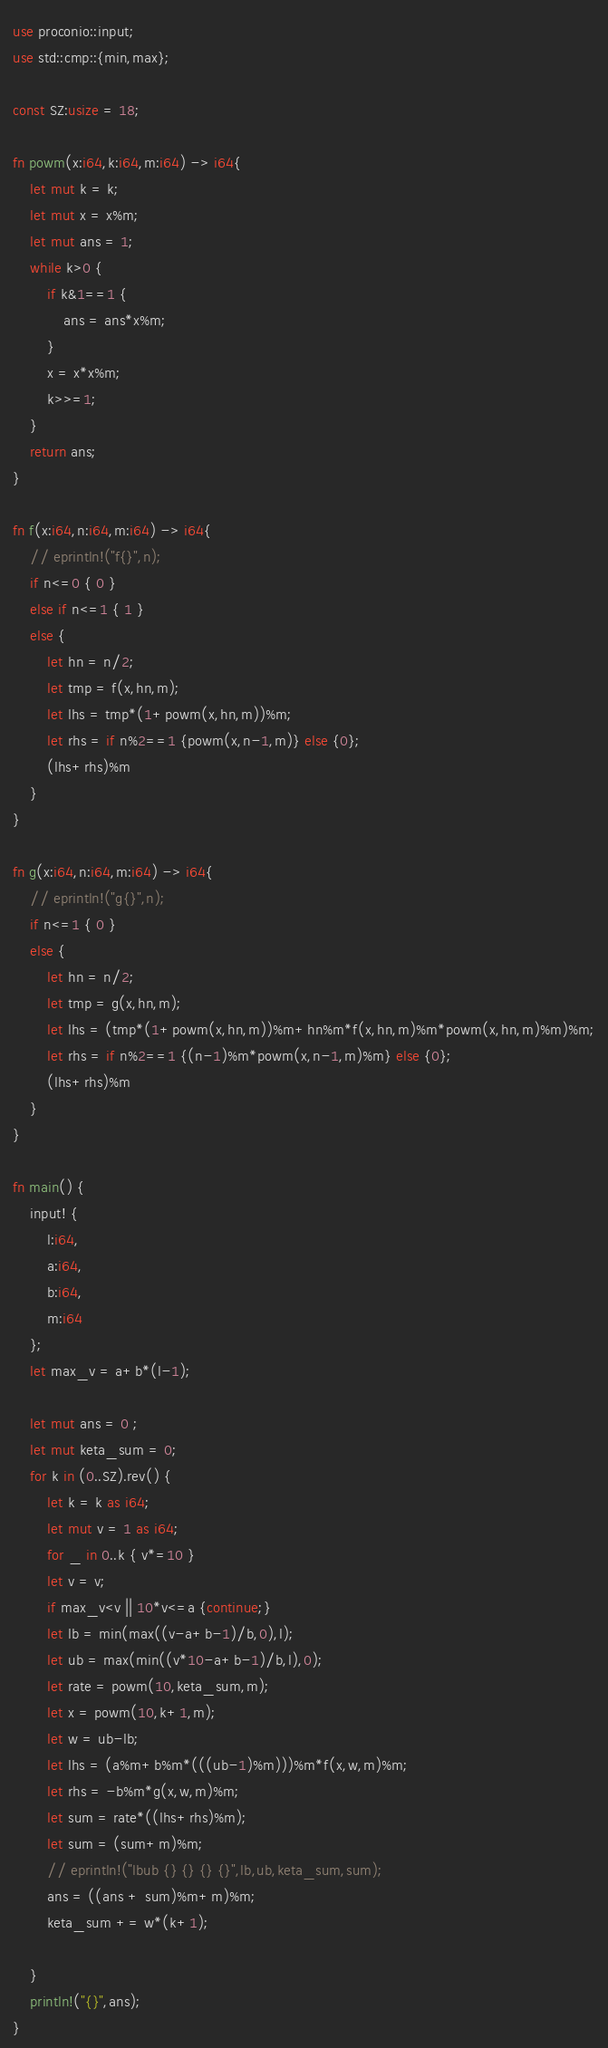Convert code to text. <code><loc_0><loc_0><loc_500><loc_500><_Rust_>use proconio::input;
use std::cmp::{min,max};

const SZ:usize = 18;

fn powm(x:i64,k:i64,m:i64) -> i64{
    let mut k = k;
    let mut x = x%m;
    let mut ans = 1;
    while k>0 {
        if k&1==1 {
            ans = ans*x%m;
        }
        x = x*x%m;
        k>>=1;
    }
    return ans;
}

fn f(x:i64,n:i64,m:i64) -> i64{
    // eprintln!("f{}",n);
    if n<=0 { 0 } 
    else if n<=1 { 1 }
    else { 
        let hn = n/2;
        let tmp = f(x,hn,m);
        let lhs = tmp*(1+powm(x,hn,m))%m;
        let rhs = if n%2==1 {powm(x,n-1,m)} else {0};
        (lhs+rhs)%m
    }
}

fn g(x:i64,n:i64,m:i64) -> i64{
    // eprintln!("g{}",n);
    if n<=1 { 0 } 
    else { 
        let hn = n/2;
        let tmp = g(x,hn,m);
        let lhs = (tmp*(1+powm(x,hn,m))%m+hn%m*f(x,hn,m)%m*powm(x,hn,m)%m)%m;
        let rhs = if n%2==1 {(n-1)%m*powm(x,n-1,m)%m} else {0};
        (lhs+rhs)%m
    }
}

fn main() {
    input! {
        l:i64,
        a:i64,
        b:i64,
        m:i64
    };
    let max_v = a+b*(l-1);

    let mut ans = 0 ;
    let mut keta_sum = 0;
    for k in (0..SZ).rev() {
        let k = k as i64;
        let mut v = 1 as i64;
        for _ in 0..k { v*=10 }
        let v = v;
        if max_v<v || 10*v<=a {continue;}
        let lb = min(max((v-a+b-1)/b,0),l);
        let ub = max(min((v*10-a+b-1)/b,l),0);
        let rate = powm(10,keta_sum,m);
        let x = powm(10,k+1,m);
        let w = ub-lb;
        let lhs = (a%m+b%m*(((ub-1)%m)))%m*f(x,w,m)%m;
        let rhs = -b%m*g(x,w,m)%m;
        let sum = rate*((lhs+rhs)%m);
        let sum = (sum+m)%m;
        // eprintln!("lbub {} {} {} {}",lb,ub,keta_sum,sum);
        ans = ((ans + sum)%m+m)%m;    
        keta_sum += w*(k+1);
        
    }
    println!("{}",ans);
}


</code> 